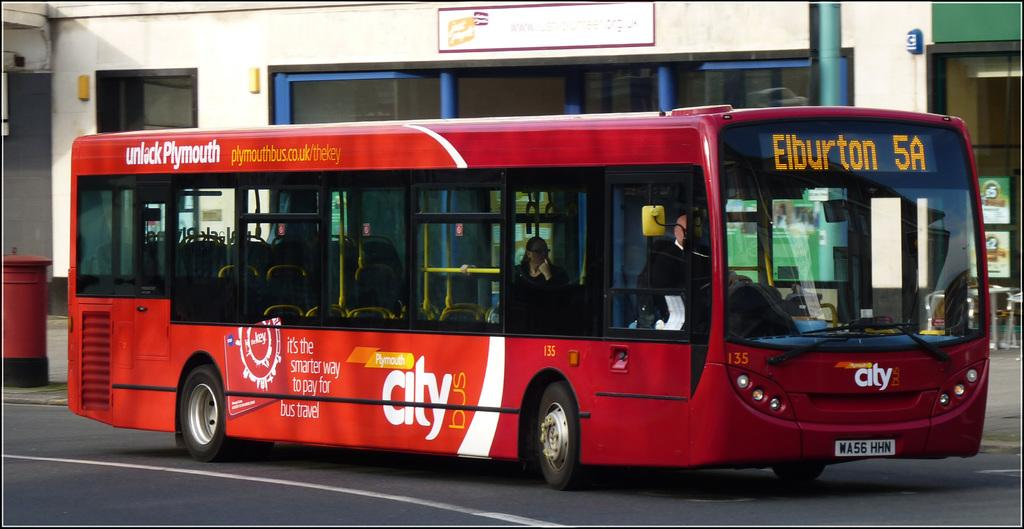What type of vehicle is in the image? There is a red color bus in the image. Where is the bus located? The bus is visible on the road. Are there any passengers in the bus? Yes, there are persons inside the bus. What can be seen in the background of the image? There are buildings visible at the top of the image. What type of collar can be seen on the sheep in the image? There are no sheep or collars present in the image. 